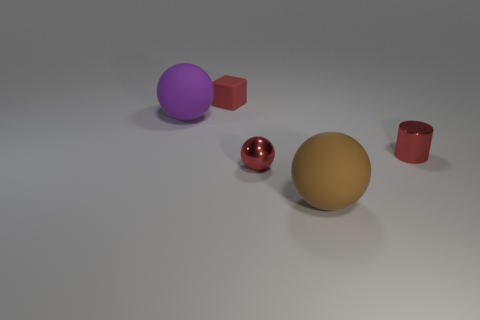Is the color of the tiny cylinder the same as the small metallic ball?
Provide a succinct answer. Yes. What number of objects are either red objects that are to the right of the big brown rubber object or big purple balls?
Give a very brief answer. 2. Is the number of matte objects that are behind the large brown rubber object greater than the number of objects behind the tiny matte object?
Ensure brevity in your answer.  Yes. How many matte objects are either blocks or red cylinders?
Your response must be concise. 1. There is a tiny block that is the same color as the small sphere; what is its material?
Your answer should be very brief. Rubber. Is the number of spheres behind the tiny red metallic cylinder less than the number of red blocks behind the tiny rubber cube?
Your answer should be compact. No. How many things are either brown matte balls or objects on the left side of the red cylinder?
Your answer should be very brief. 4. There is a cube that is the same size as the shiny cylinder; what is it made of?
Your response must be concise. Rubber. Is the material of the red ball the same as the big purple object?
Provide a succinct answer. No. What is the color of the small object that is both in front of the tiny cube and behind the metal sphere?
Your response must be concise. Red. 